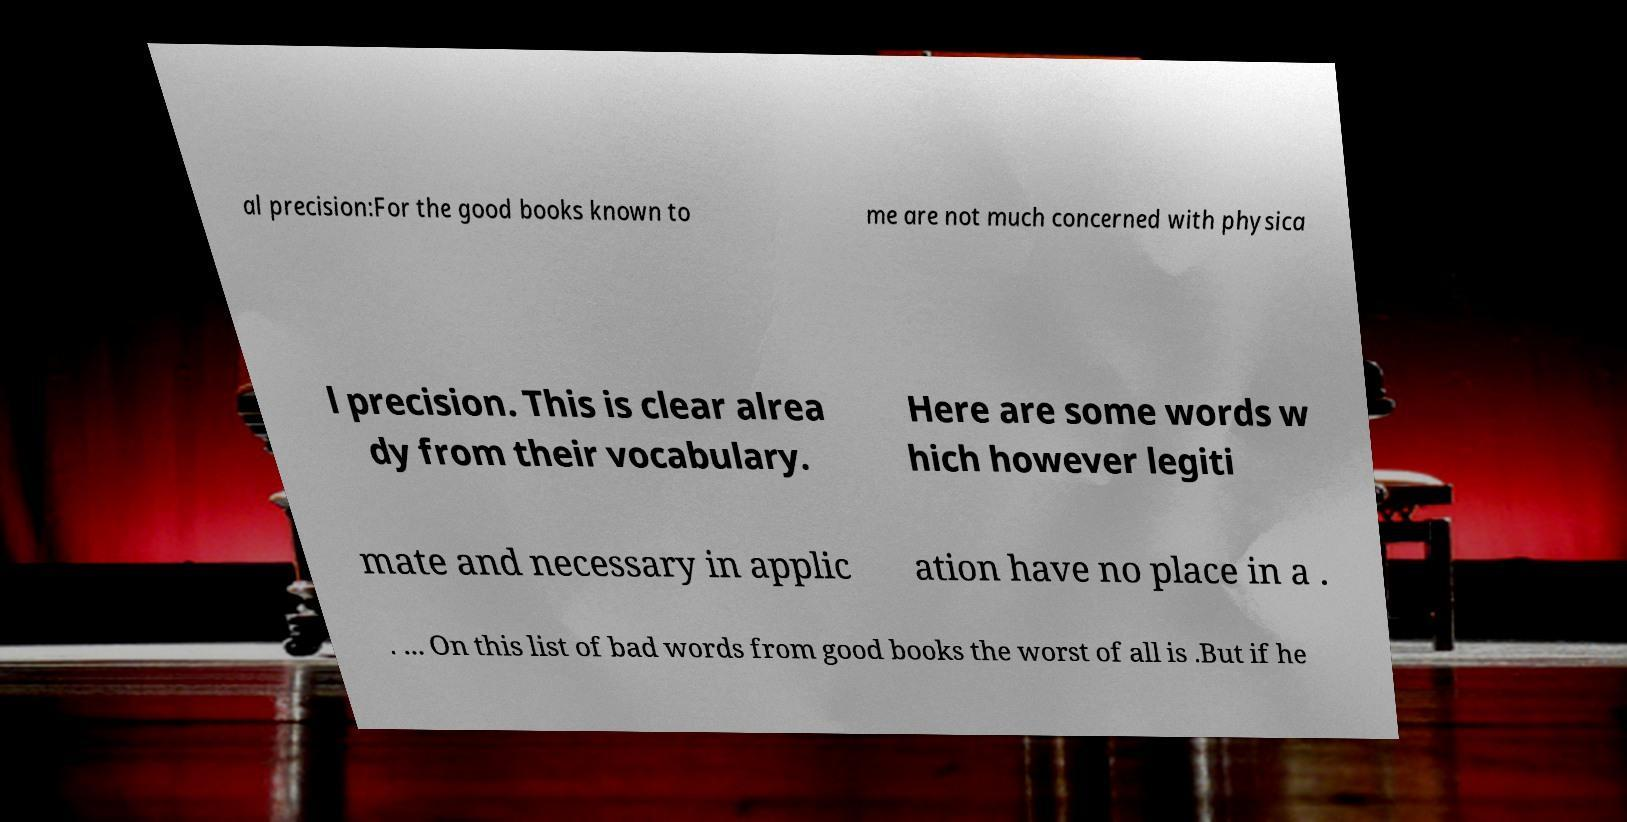I need the written content from this picture converted into text. Can you do that? al precision:For the good books known to me are not much concerned with physica l precision. This is clear alrea dy from their vocabulary. Here are some words w hich however legiti mate and necessary in applic ation have no place in a . . ... On this list of bad words from good books the worst of all is .But if he 